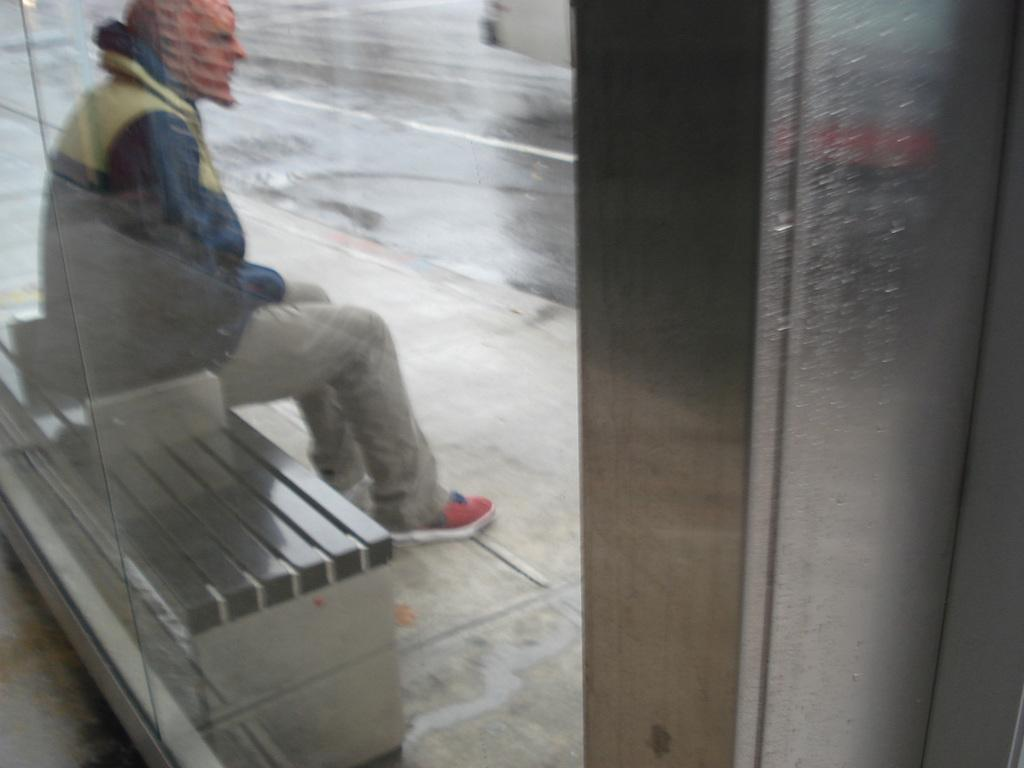What is the main subject of the image? There is a person in the image. What is the person doing in the image? The person is sitting on a bench. What type of flower can be seen growing near the seashore in the image? There is no flower or seashore present in the image; it only features a person sitting on a bench. 